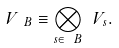Convert formula to latex. <formula><loc_0><loc_0><loc_500><loc_500>\ V _ { \ B } \equiv \bigotimes _ { s \in \ B } \ V _ { s } .</formula> 